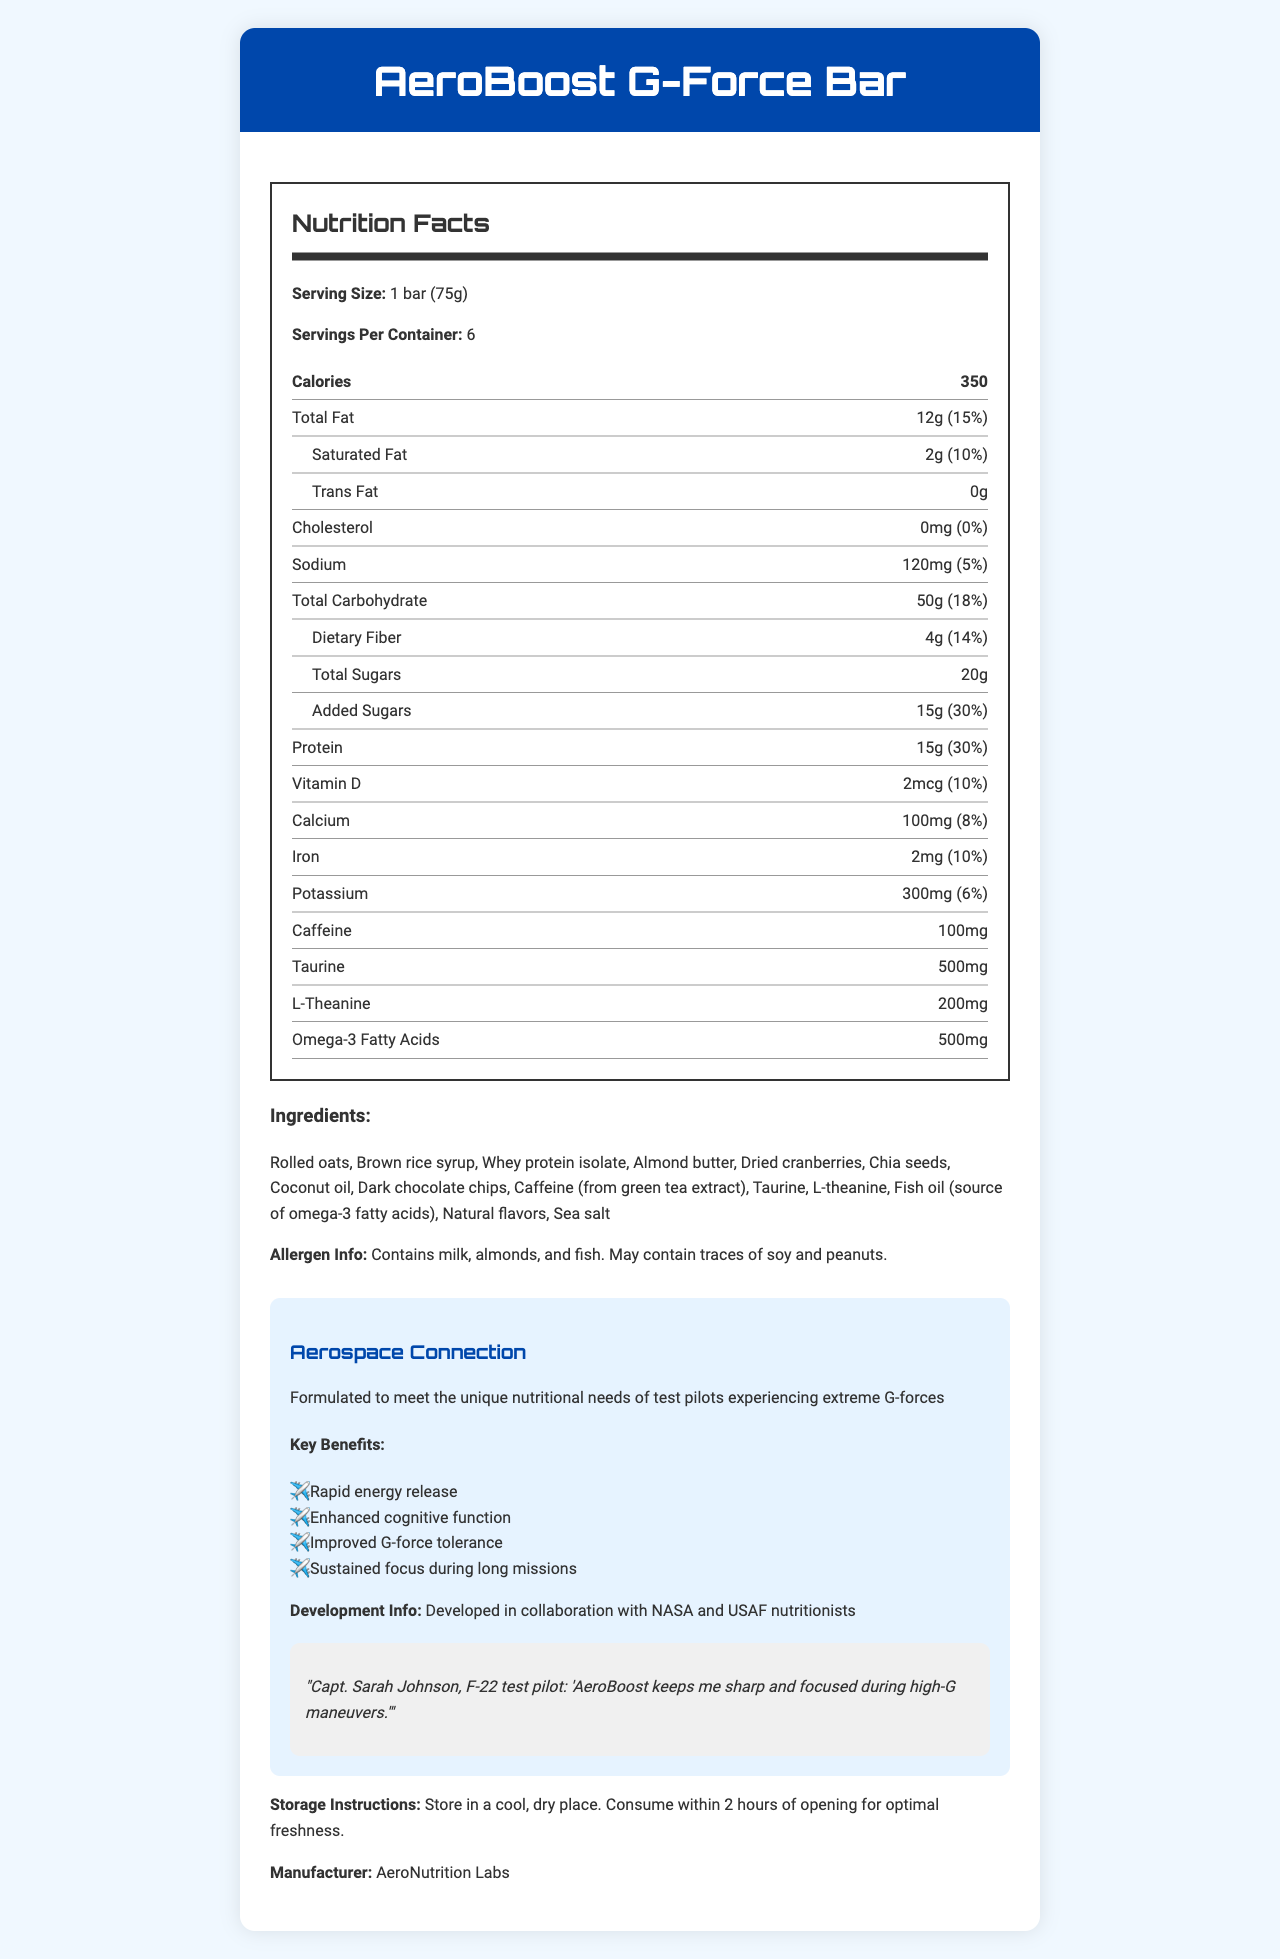what is the serving size of the AeroBoost G-Force Bar? The serving size is explicitly stated as "1 bar (75g)" in the Nutrition Facts section.
Answer: 1 bar (75g) how many calories are there per serving? The document lists "Calories: 350" in the Nutrition Facts section.
Answer: 350 what is the total fat content per serving? The total fat content is shown as "Total Fat: 12g" in the Nutrition Facts section.
Answer: 12g how much dietary fiber is in one serving of the bar? The dietary fiber content is listed as "Dietary Fiber: 4g" in the Nutrition Facts section.
Answer: 4g specify the amount of caffeine in each bar. The caffeine content is clearly labeled as "Caffeine: 100mg" in the Nutrition Facts section.
Answer: 100mg which ingredient is a source of omega-3 fatty acids? A. Almond butter B. Fish oil C. Chia seeds D. Coconut oil The document states "Fish oil (source of omega-3 fatty acids)" in the ingredients list.
Answer: B who collaborated in developing the AeroBoost G-Force Bar? A. NASA and USAF nutritionists B. FDA and CDC C. MIT and Harvard D. WHO and UNICEF The development information explicitly mentions, "Developed in collaboration with NASA and USAF nutritionists."
Answer: A does the AeroBoost G-Force Bar contain any trans fat? The Nutrition Facts section shows "Trans Fat: 0g," indicating there is no trans fat.
Answer: No describe the key benefits of the AeroBoost G-Force Bar. This summary can be found in the section that lists the key benefits under Aerospace Connection.
Answer: Rapid energy release, enhanced cognitive function, improved G-force tolerance, sustained focus during long missions who is the manufacturer of AeroBoost G-Force Bar? This information is clearly stated at the end of the document as "Manufacturer: AeroNutrition Labs."
Answer: AeroNutrition Labs can this document provide information on where to purchase the AeroBoost G-Force Bar? The document does not mention any details about purchasing or retail availability.
Answer: Not enough information how many servings are there per container? This information is listed as "Servings Per Container: 6" in the Nutrition Facts section.
Answer: 6 how much protein is provided per serving, in both grams and daily value percentage? The protein content is given as "Protein: 15g (30%)" in the Nutrition Facts section.
Answer: 15g (30%) what is the primary role of Capt. Sarah Johnson as related to the bar? The document states, "Capt. Sarah Johnson, F-22 test pilot: 'AeroBoost keeps me sharp and focused during high-G maneuvers.'"
Answer: Test pilot providing testimonial how should the AeroBoost G-Force Bar be stored? This information is provided in the storage instructions section at the end of the document.
Answer: Store in a cool, dry place. Consume within 2 hours of opening for optimal freshness. 